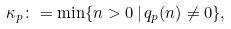<formula> <loc_0><loc_0><loc_500><loc_500>\kappa _ { p } \colon = \min \{ n > 0 \, | \, q _ { p } ( n ) \not = 0 \} ,</formula> 